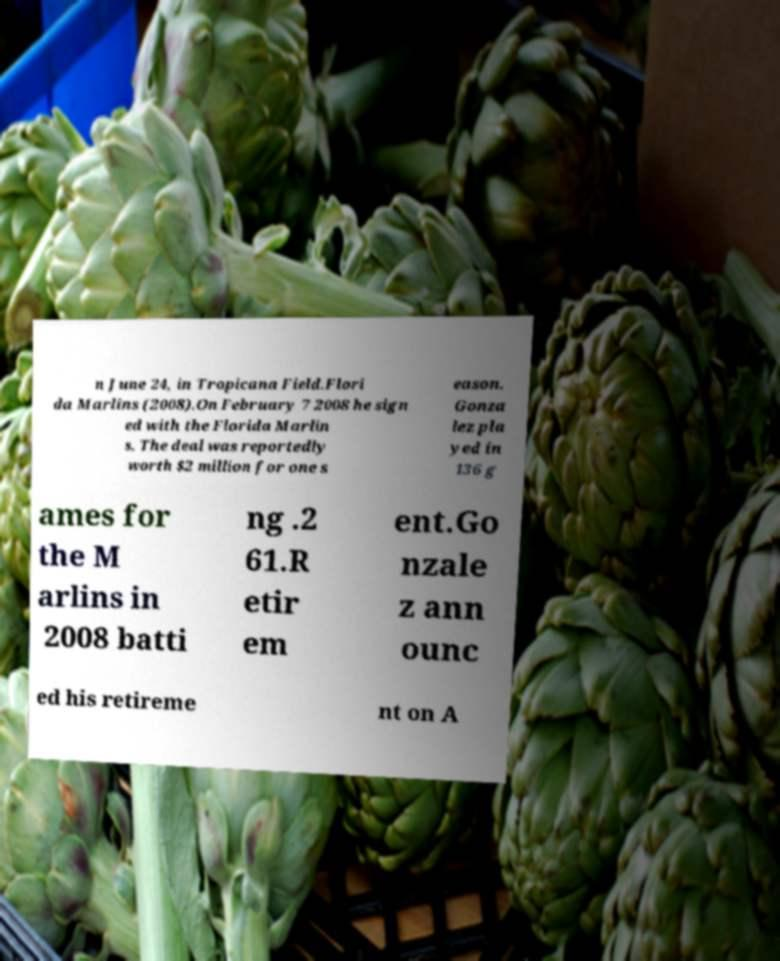Can you read and provide the text displayed in the image?This photo seems to have some interesting text. Can you extract and type it out for me? n June 24, in Tropicana Field.Flori da Marlins (2008).On February 7 2008 he sign ed with the Florida Marlin s. The deal was reportedly worth $2 million for one s eason. Gonza lez pla yed in 136 g ames for the M arlins in 2008 batti ng .2 61.R etir em ent.Go nzale z ann ounc ed his retireme nt on A 